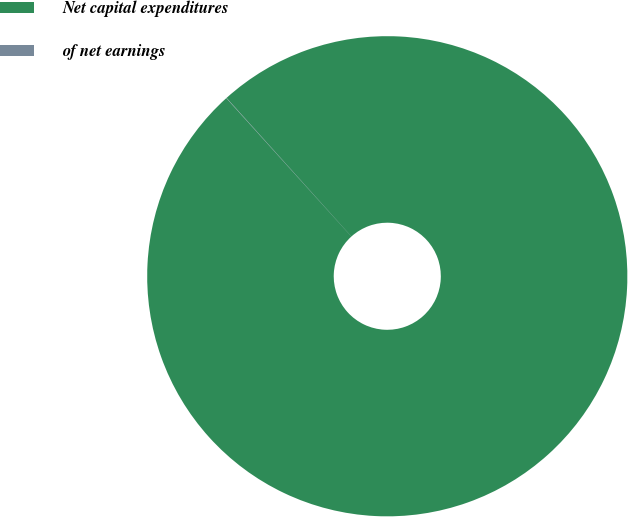Convert chart to OTSL. <chart><loc_0><loc_0><loc_500><loc_500><pie_chart><fcel>Net capital expenditures<fcel>of net earnings<nl><fcel>99.98%<fcel>0.02%<nl></chart> 